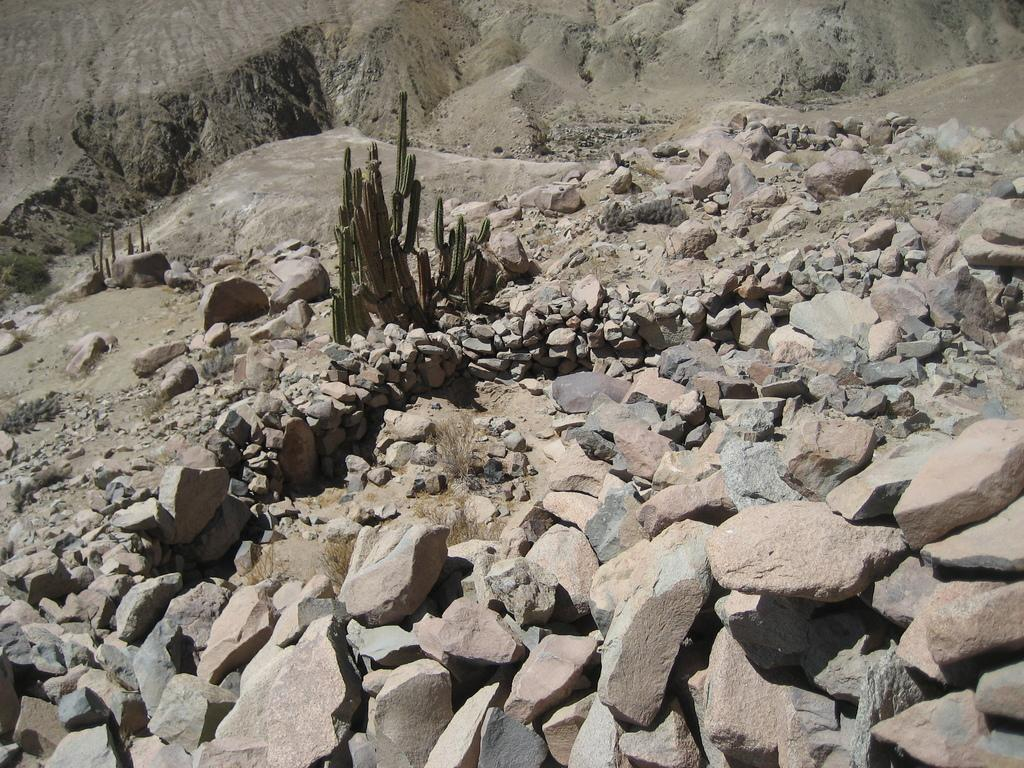What type of plants are in the image? There are cactus plants in the image. Where are the cactus plants located? The cactus plants are on rocks. What can be seen in the background of the image? There is a mountain visible in the background of the image. What type of toys can be seen on the mountain in the image? There are no toys present in the image, and the mountain is in the background, not the foreground. 